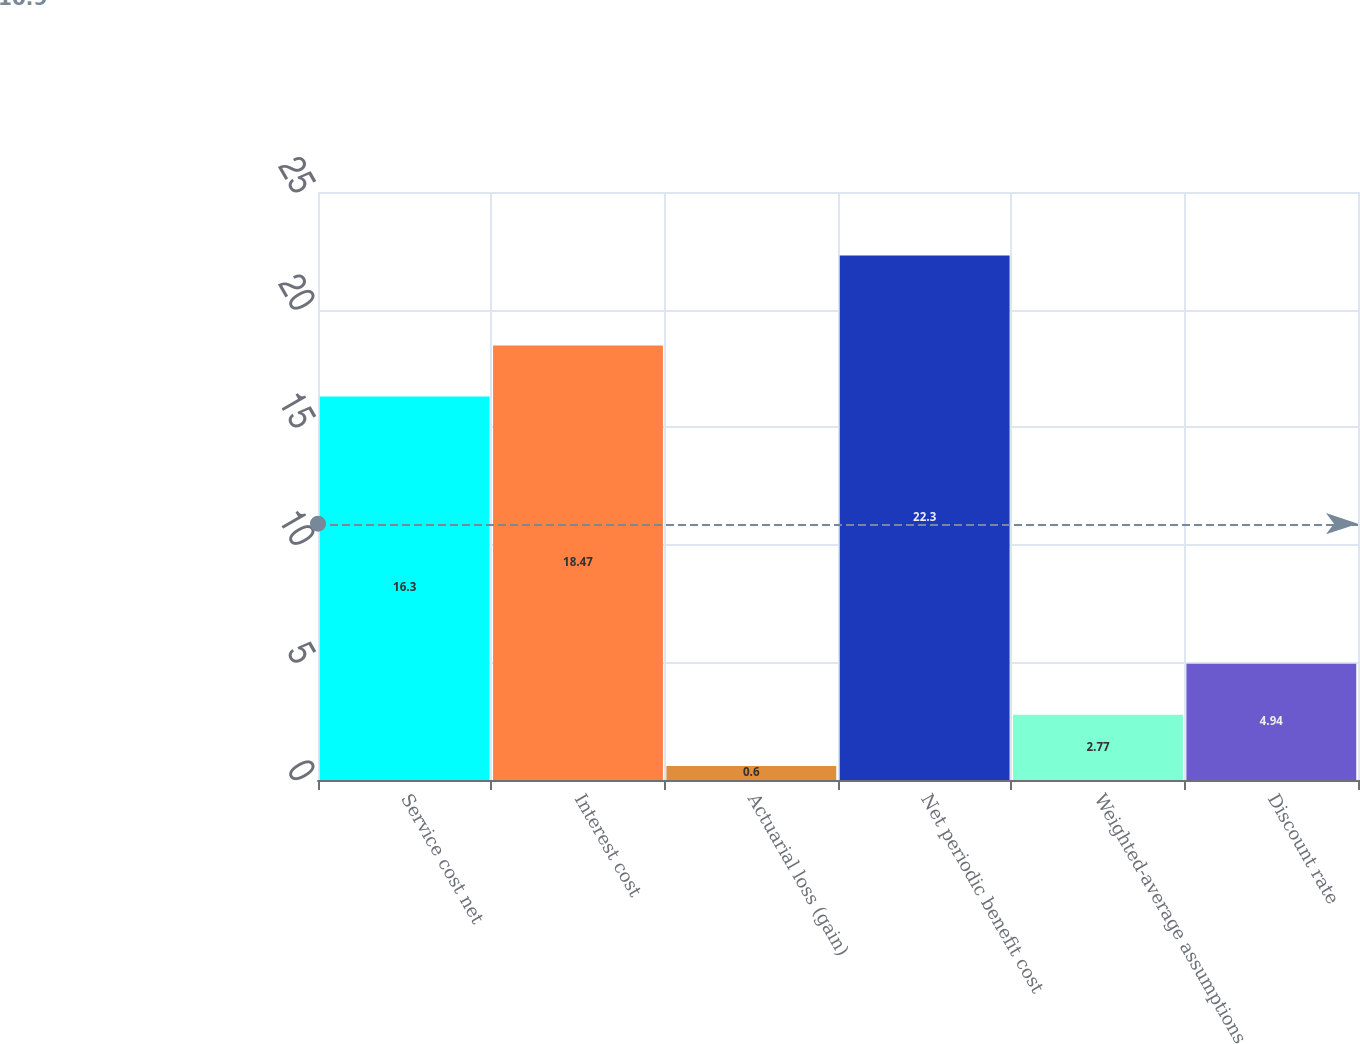Convert chart to OTSL. <chart><loc_0><loc_0><loc_500><loc_500><bar_chart><fcel>Service cost net<fcel>Interest cost<fcel>Actuarial loss (gain)<fcel>Net periodic benefit cost<fcel>Weighted-average assumptions<fcel>Discount rate<nl><fcel>16.3<fcel>18.47<fcel>0.6<fcel>22.3<fcel>2.77<fcel>4.94<nl></chart> 